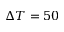Convert formula to latex. <formula><loc_0><loc_0><loc_500><loc_500>\Delta T = 5 0</formula> 